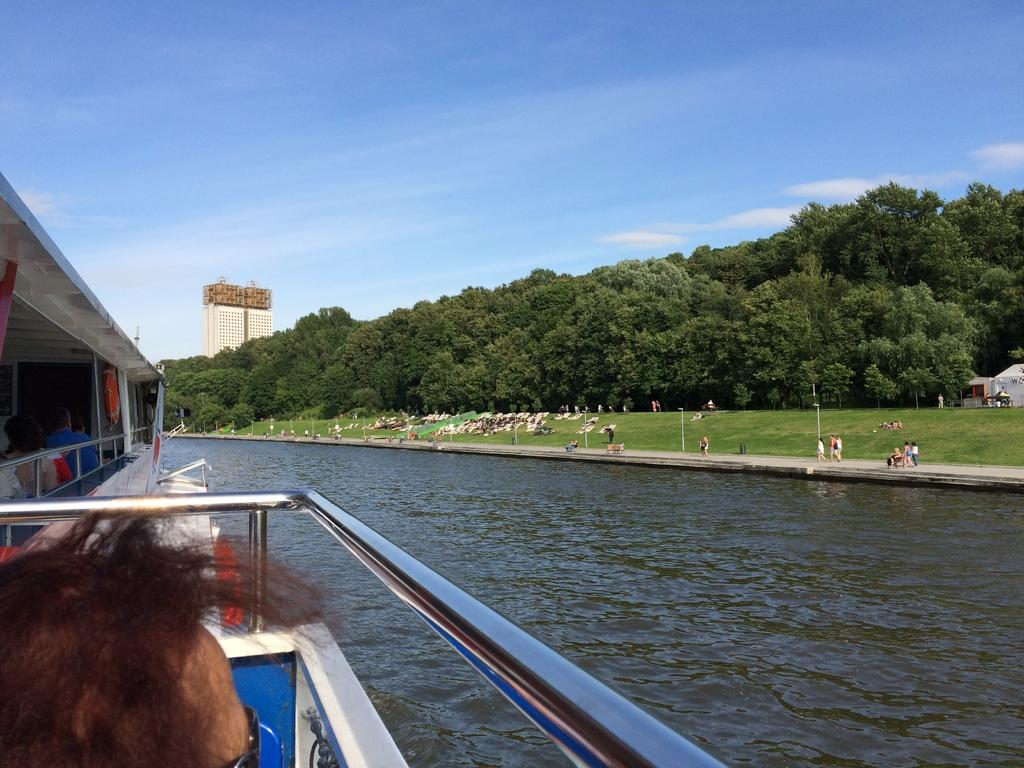What is the main subject of the image? There is a ship in the image. What can be seen on the right side of the image? There is water on the right side of the image. What is visible in the background of the image? People, trees, and green grass on the ground are present in the background of the image. What is visible at the top of the image? The sky is visible at the top of the image. How many pairs of scissors are being used by the boys in the image? There are no boys or scissors present in the image. 